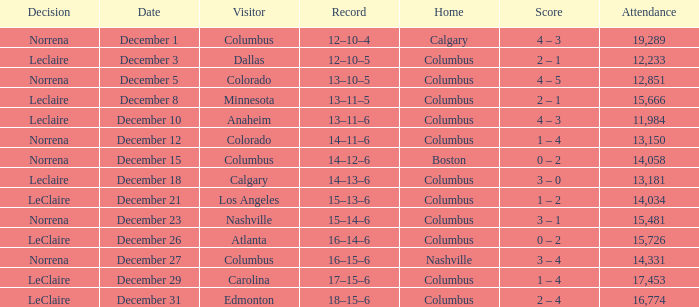Write the full table. {'header': ['Decision', 'Date', 'Visitor', 'Record', 'Home', 'Score', 'Attendance'], 'rows': [['Norrena', 'December 1', 'Columbus', '12–10–4', 'Calgary', '4 – 3', '19,289'], ['Leclaire', 'December 3', 'Dallas', '12–10–5', 'Columbus', '2 – 1', '12,233'], ['Norrena', 'December 5', 'Colorado', '13–10–5', 'Columbus', '4 – 5', '12,851'], ['Leclaire', 'December 8', 'Minnesota', '13–11–5', 'Columbus', '2 – 1', '15,666'], ['Leclaire', 'December 10', 'Anaheim', '13–11–6', 'Columbus', '4 – 3', '11,984'], ['Norrena', 'December 12', 'Colorado', '14–11–6', 'Columbus', '1 – 4', '13,150'], ['Norrena', 'December 15', 'Columbus', '14–12–6', 'Boston', '0 – 2', '14,058'], ['Leclaire', 'December 18', 'Calgary', '14–13–6', 'Columbus', '3 – 0', '13,181'], ['LeClaire', 'December 21', 'Los Angeles', '15–13–6', 'Columbus', '1 – 2', '14,034'], ['Norrena', 'December 23', 'Nashville', '15–14–6', 'Columbus', '3 – 1', '15,481'], ['LeClaire', 'December 26', 'Atlanta', '16–14–6', 'Columbus', '0 – 2', '15,726'], ['Norrena', 'December 27', 'Columbus', '16–15–6', 'Nashville', '3 – 4', '14,331'], ['LeClaire', 'December 29', 'Carolina', '17–15–6', 'Columbus', '1 – 4', '17,453'], ['LeClaire', 'December 31', 'Edmonton', '18–15–6', 'Columbus', '2 – 4', '16,774']]} What was the score with a 16–14–6 record? 0 – 2. 